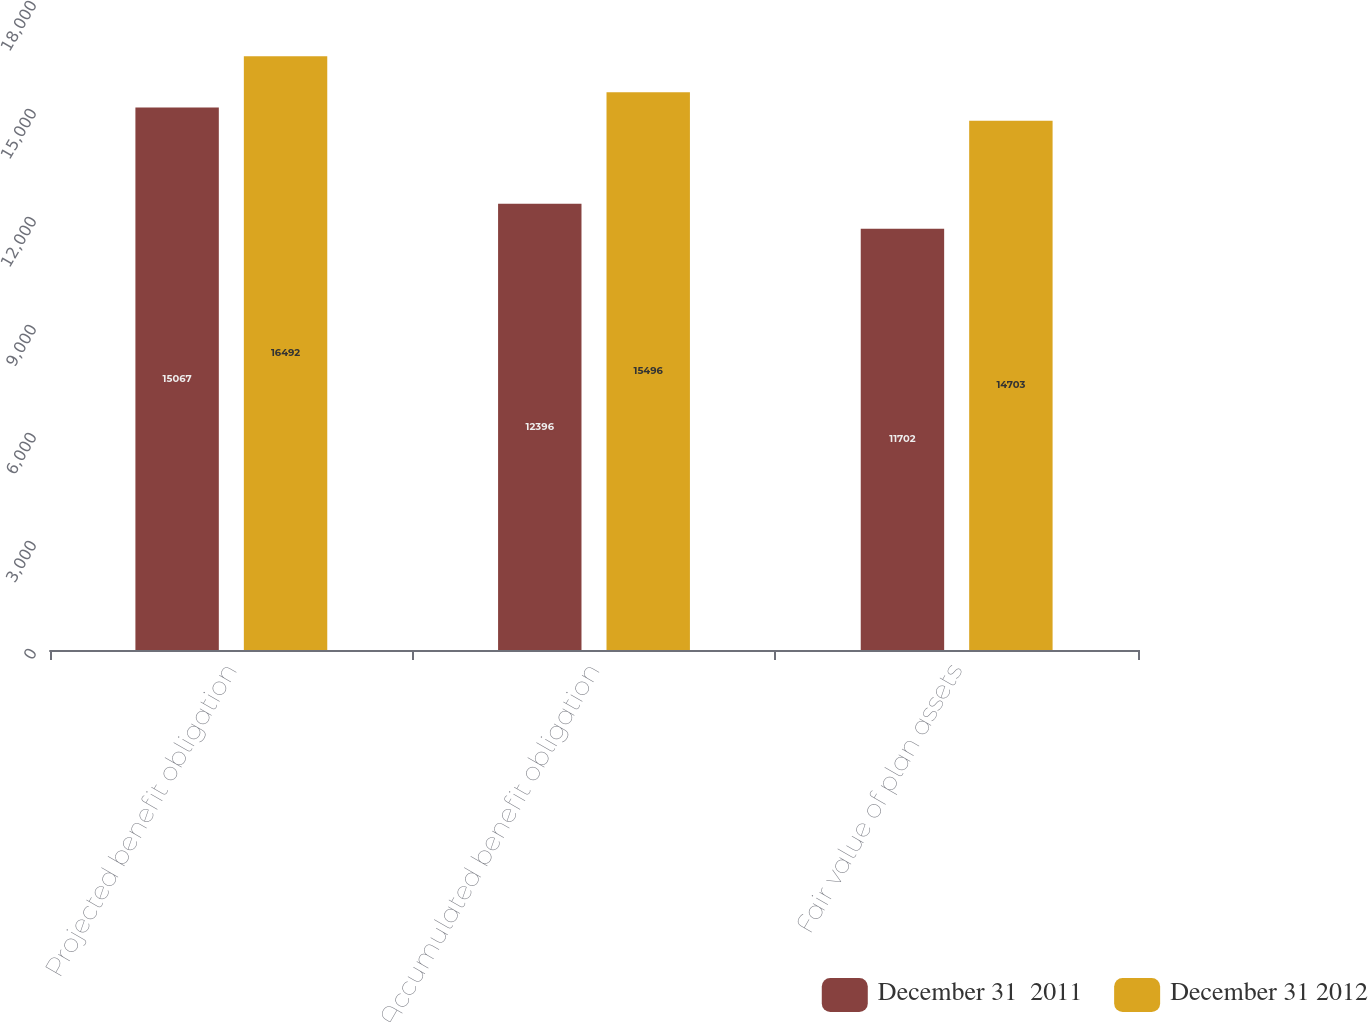Convert chart. <chart><loc_0><loc_0><loc_500><loc_500><stacked_bar_chart><ecel><fcel>Projected benefit obligation<fcel>Accumulated benefit obligation<fcel>Fair value of plan assets<nl><fcel>December 31  2011<fcel>15067<fcel>12396<fcel>11702<nl><fcel>December 31 2012<fcel>16492<fcel>15496<fcel>14703<nl></chart> 